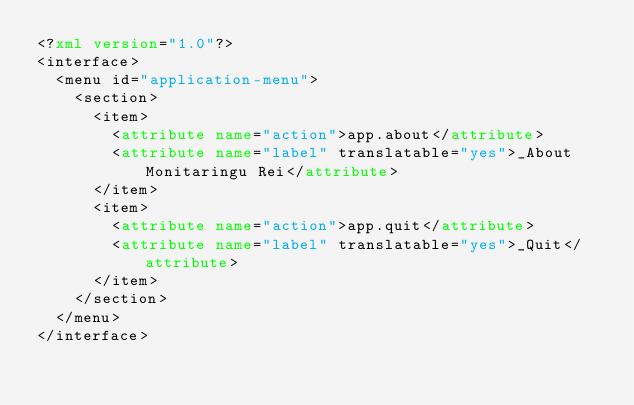Convert code to text. <code><loc_0><loc_0><loc_500><loc_500><_XML_><?xml version="1.0"?>
<interface>
  <menu id="application-menu">
    <section>
      <item>
        <attribute name="action">app.about</attribute>
        <attribute name="label" translatable="yes">_About Monitaringu Rei</attribute>
      </item>
      <item>
        <attribute name="action">app.quit</attribute>
        <attribute name="label" translatable="yes">_Quit</attribute>
      </item>
    </section>
  </menu>
</interface>
</code> 